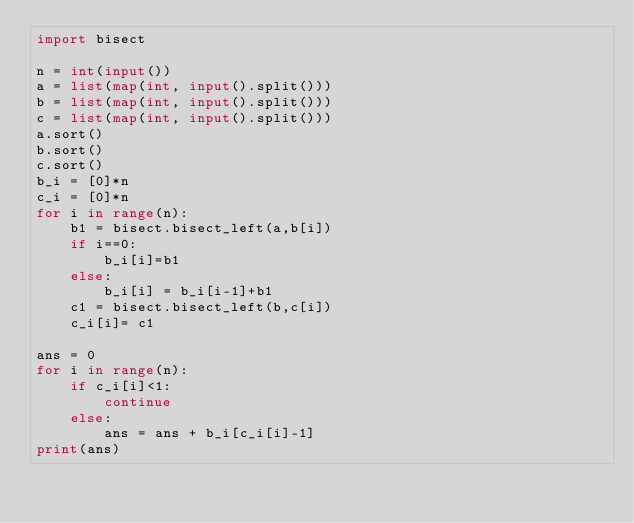<code> <loc_0><loc_0><loc_500><loc_500><_Python_>import bisect

n = int(input())
a = list(map(int, input().split()))
b = list(map(int, input().split()))
c = list(map(int, input().split()))
a.sort()
b.sort()
c.sort()
b_i = [0]*n
c_i = [0]*n
for i in range(n):
    b1 = bisect.bisect_left(a,b[i])
    if i==0:
        b_i[i]=b1
    else:
        b_i[i] = b_i[i-1]+b1
    c1 = bisect.bisect_left(b,c[i])
    c_i[i]= c1

ans = 0
for i in range(n):
    if c_i[i]<1:
        continue
    else:
        ans = ans + b_i[c_i[i]-1]
print(ans)</code> 